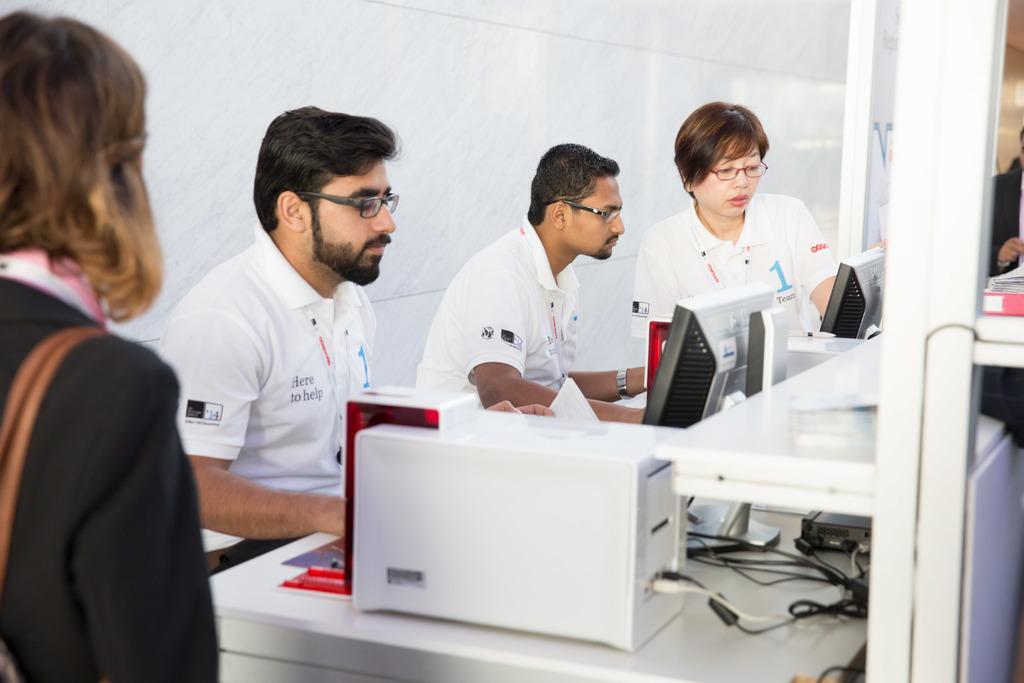How would you summarize this image in a sentence or two? In the image few people are sitting and looking into the monitors. Behind them there is a wall. 